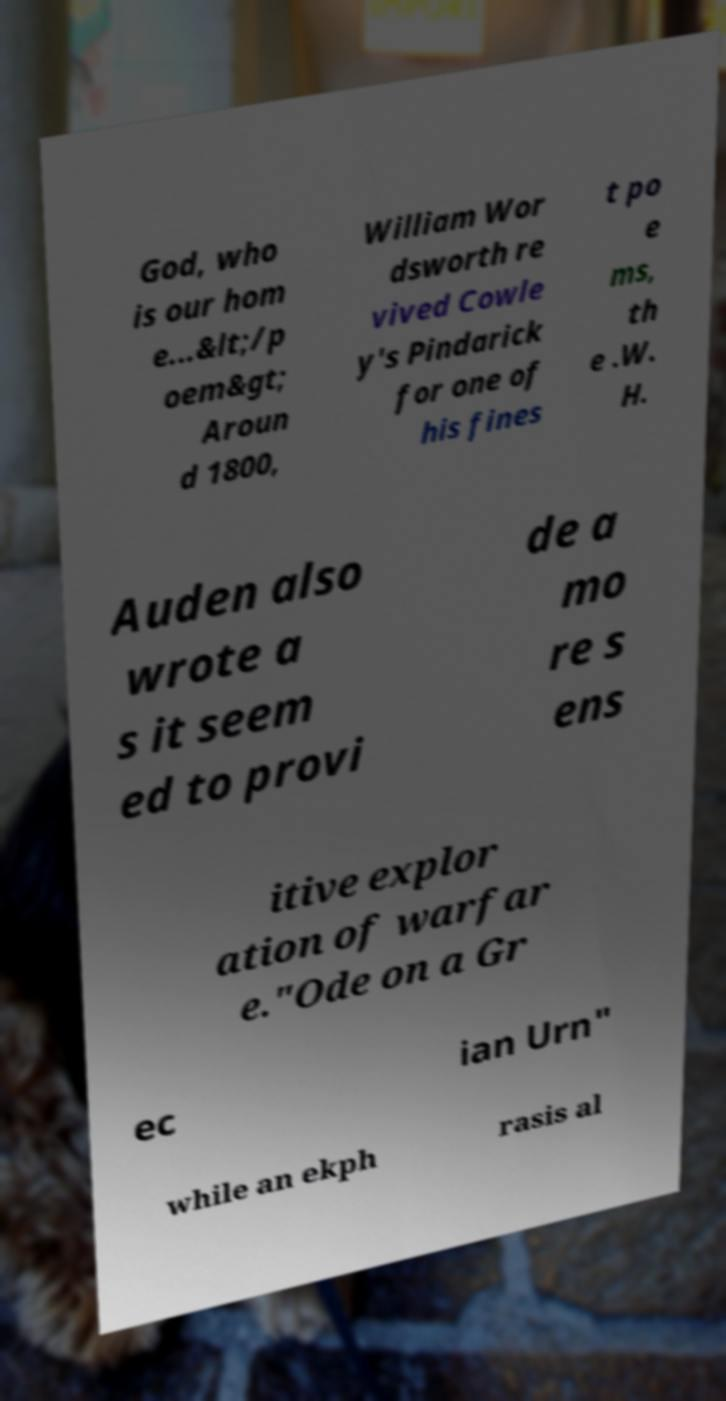Can you accurately transcribe the text from the provided image for me? God, who is our hom e...&lt;/p oem&gt; Aroun d 1800, William Wor dsworth re vived Cowle y's Pindarick for one of his fines t po e ms, th e .W. H. Auden also wrote a s it seem ed to provi de a mo re s ens itive explor ation of warfar e."Ode on a Gr ec ian Urn" while an ekph rasis al 